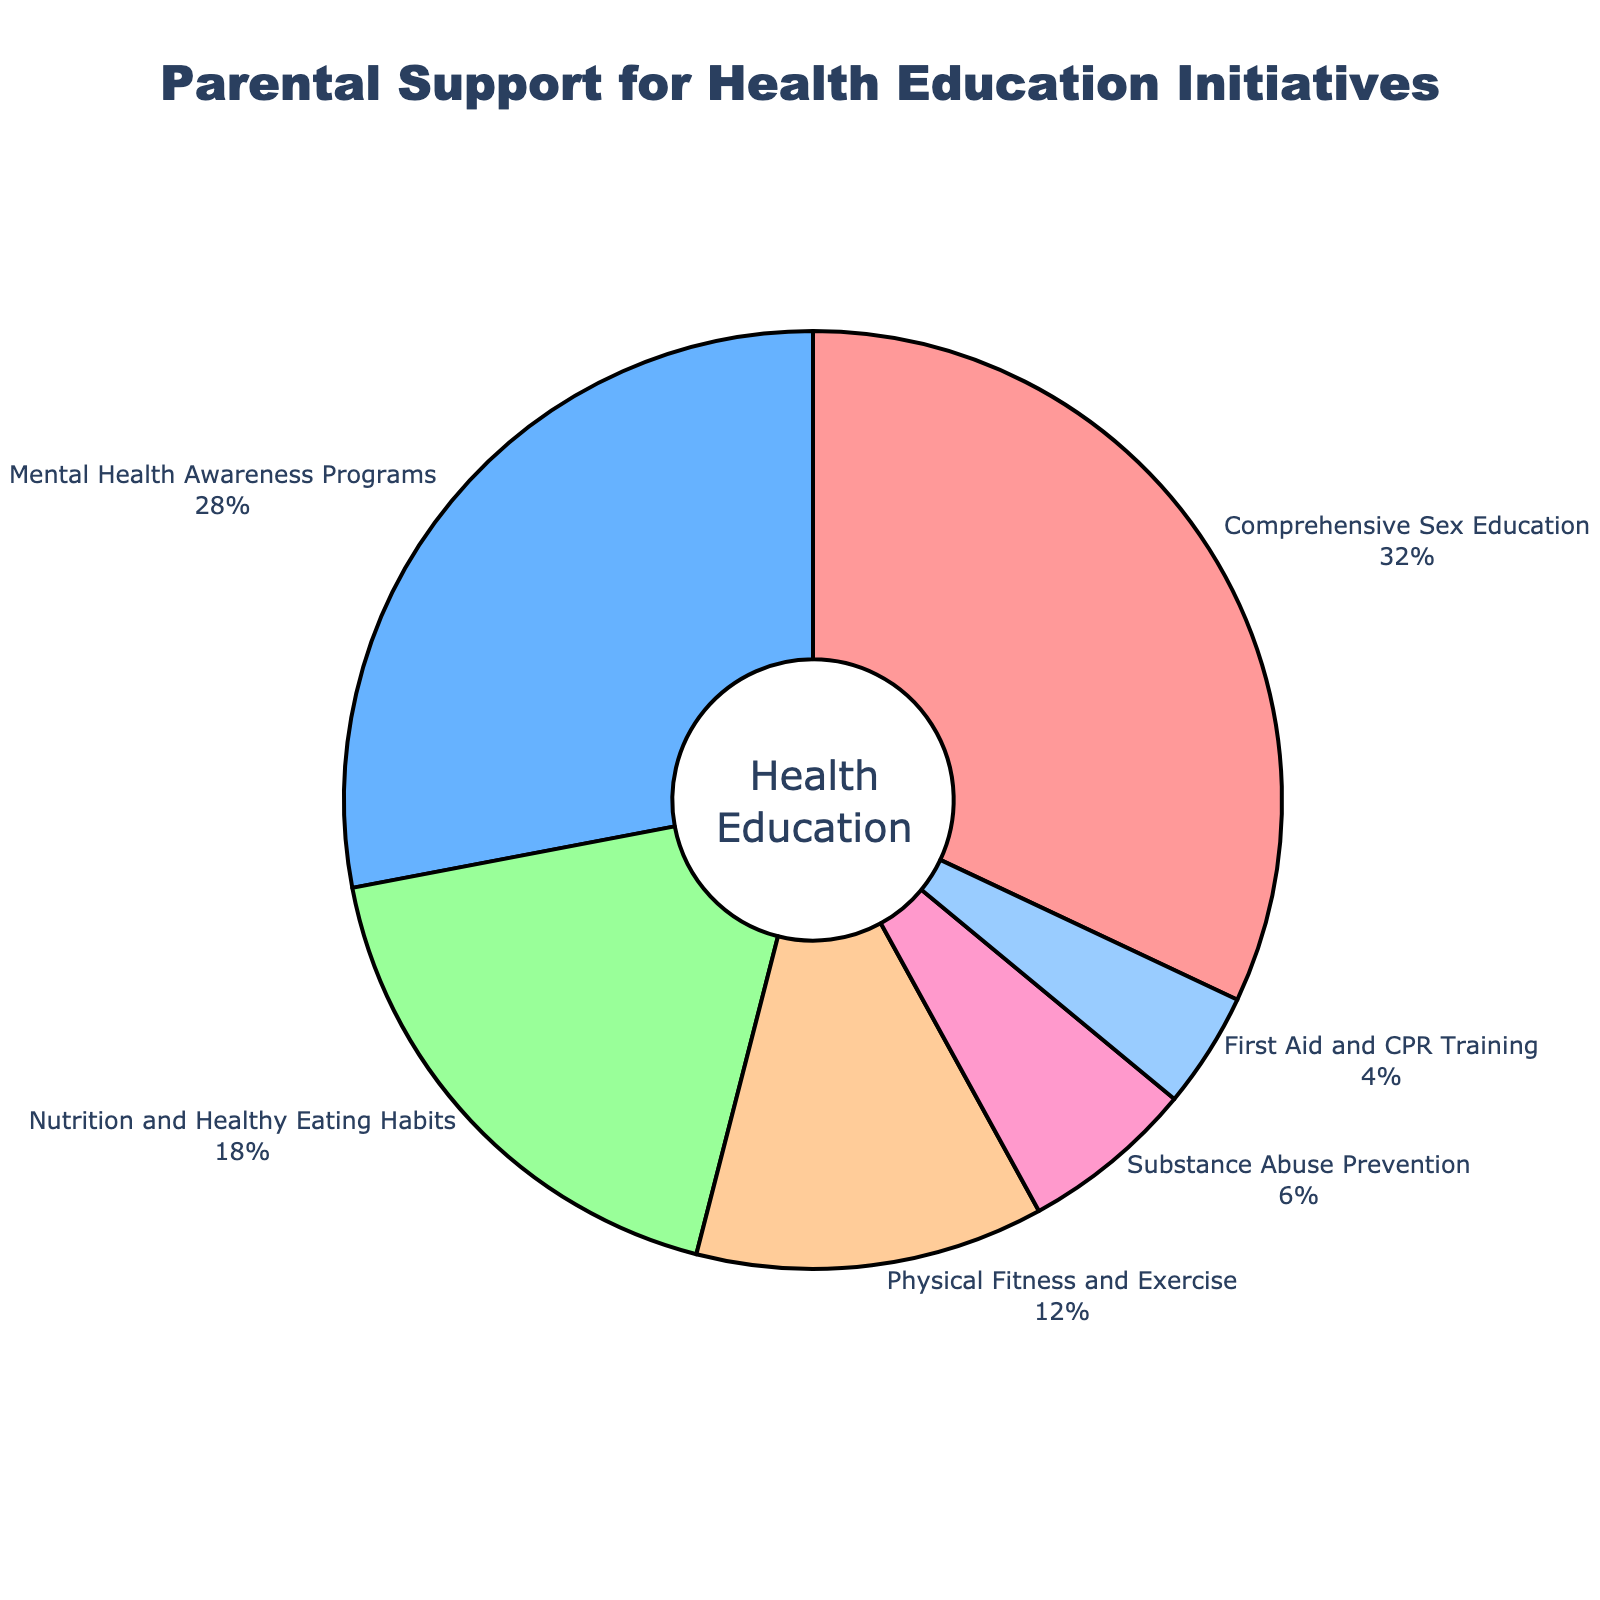What's the total percentage of parental support for both Comprehensive Sex Education and Mental Health Awareness Programs? Sum the percentages of Comprehensive Sex Education (32%) and Mental Health Awareness Programs (28%): 32 + 28 = 60
Answer: 60 Which initiative has the least parental support, and what is the percentage? Examine the pie chart to find the smallest slice, which corresponds to First Aid and CPR Training at 4%
Answer: First Aid and CPR Training, 4% Is parental support for Physical Fitness and Exercise higher or lower than for Nutrition and Healthy Eating Habits? Compare the percentages: Physical Fitness and Exercise is 12%, and Nutrition and Healthy Eating Habits is 18%. Since 12 < 18, support for Physical Fitness and Exercise is lower
Answer: Lower What's the difference in parental support percentages between the initiative with the most support and the one with the least support? Identify the highest support (Comprehensive Sex Education at 32%) and the lowest support (First Aid and CPR Training at 4%). Calculate the difference: 32 - 4 = 28
Answer: 28 How much more support does Mental Health Awareness Programs have compared to Substance Abuse Prevention? Compare the percentages: Mental Health Awareness Programs at 28% and Substance Abuse Prevention at 6%. The difference is 28 - 6 = 22
Answer: 22 Which initiative falls in the middle in terms of parental support, and what color represents it? Identify the percentages in ascending order: 4%, 6%, 12%, 18%, 28%, 32%. The middle value is Nutrition and Healthy Eating Habits at 18%, represented by the third color from the legend
Answer: Nutrition and Healthy Eating Habits, light green What is the combined percentage of support for the initiatives related to physical health? Combine the percentages for Nutrition and Healthy Eating Habits (18%), Physical Fitness and Exercise (12%), and First Aid and CPR Training (4%): 18 + 12 + 4 = 34
Answer: 34 How many initiatives have less than 10% parental support, and what are they? Identify initiatives under 10%: Substance Abuse Prevention (6%) and First Aid and CPR Training (4%), totaling 2 initiatives
Answer: 2, Substance Abuse Prevention and First Aid and CPR Training Which category makes up one third of the total support, and what is its significance? Comprehensive Sex Education is 32%, very close to one third of 100%. Significance: high parental emphasis on comprehensive sex education in schools
Answer: Comprehensive Sex Education, high significance 